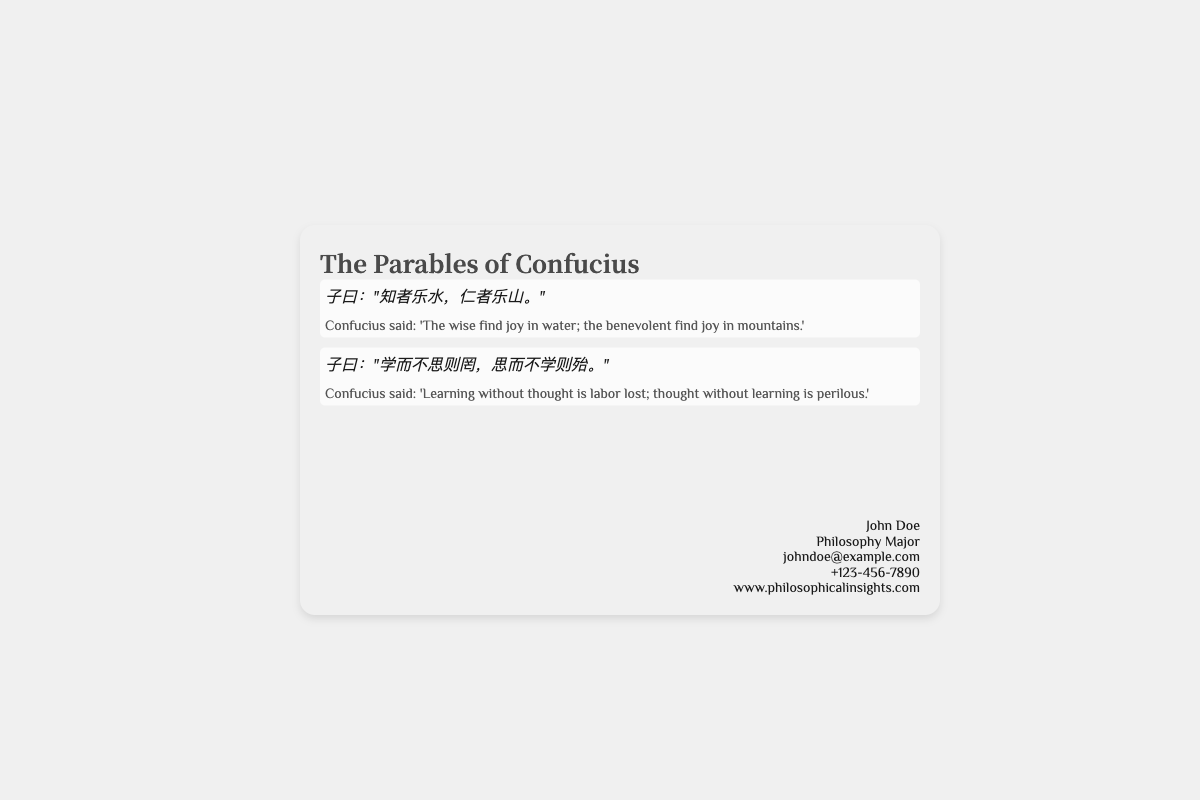What is the title of the document? The title is the main heading presented in the document, which is prominently displayed.
Answer: The Parables of Confucius Who is the author of the business card? The author is identified in the footer section of the card.
Answer: John Doe What is the email address listed on the card? The email address is provided in the footer section for contact purposes.
Answer: johndoe@example.com What philosophical principle highlights learning from others? This principle is mentioned in a quoted parable by Confucius.
Answer: When three people walk together, there must be a teacher among them Which quote emphasizes empathy? The quote that highlights the concept of the Golden Rule and moral conduct relates to personal desires and imposition on others.
Answer: Do not impose on others what you yourself do not desire What is the significance of the bamboo motif on the card? The bamboo motif is an aesthetic choice that reflects a cultural or philosophical theme associated with tranquility and wisdom.
Answer: Elegance and tranquility How many quotes are presented on the card? The card features multiple quotes, counting both the front and back.
Answer: Five quotes What does the card's design suggest about its content? The sleek and elegant design implies a focus on philosophy and wisdom, which aligns with the theme of the parables.
Answer: Timeless wisdom What is the purpose of the highlights on the card? The highlights are used to draw attention to key quotes and their translations for better visibility and emphasis.
Answer: Emphasize key quotes 